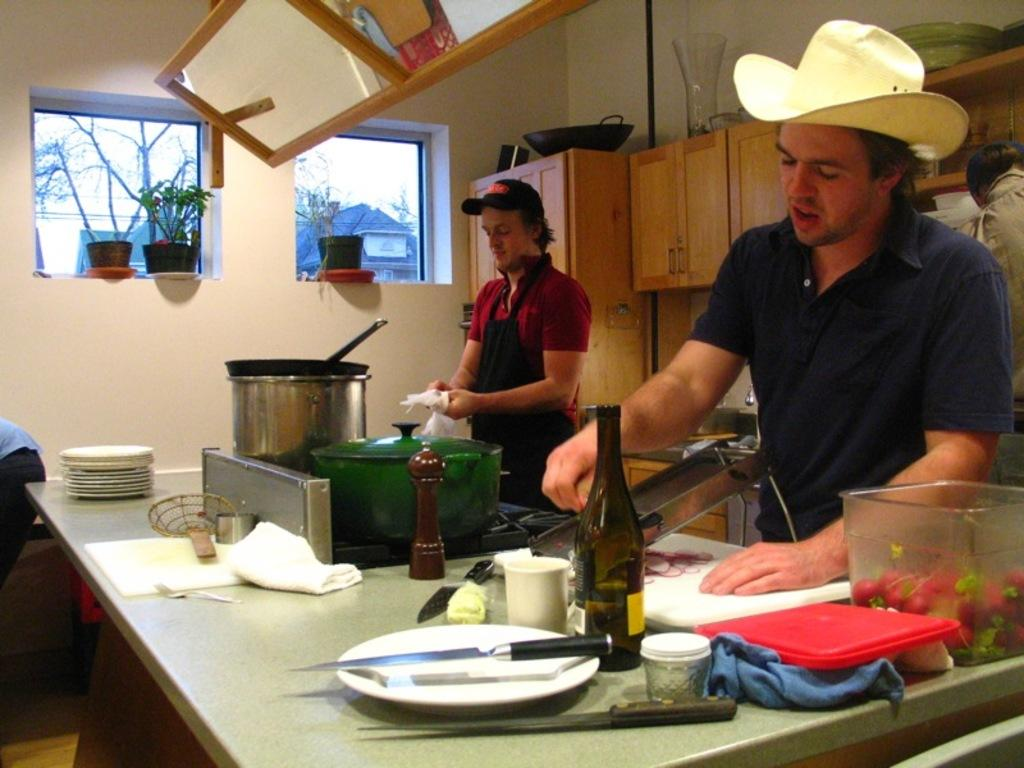How many people are in the image? There are two men in the image. Where are the men located in the image? The men are in a kitchen. What are the men doing in the image? The men are preparing a dish. What direction is the band facing in the image? There is no band present in the image, so it is not possible to determine the direction they might be facing. 